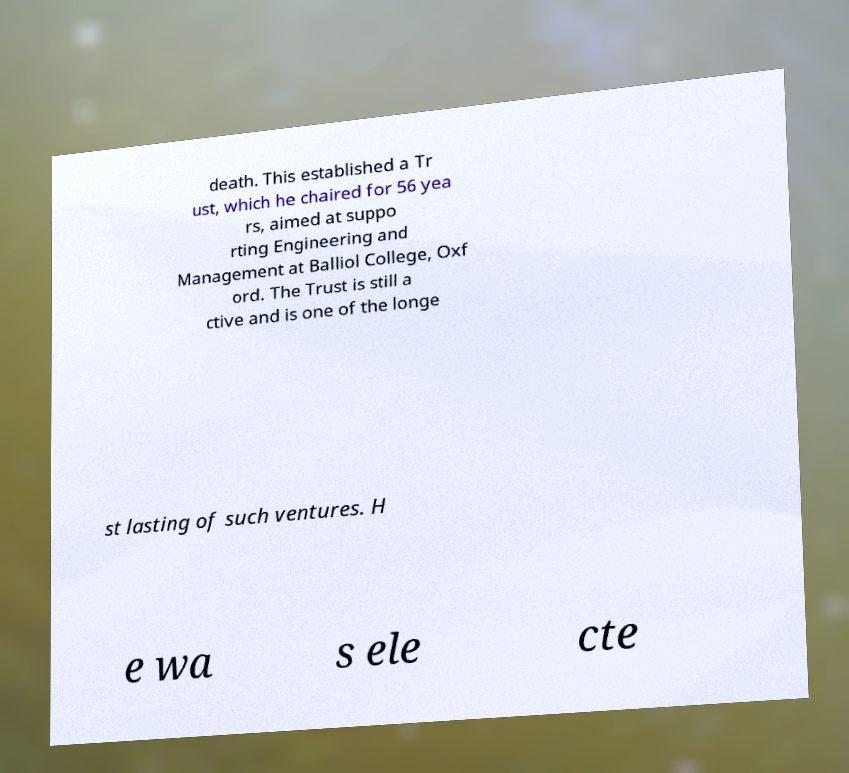Please read and relay the text visible in this image. What does it say? death. This established a Tr ust, which he chaired for 56 yea rs, aimed at suppo rting Engineering and Management at Balliol College, Oxf ord. The Trust is still a ctive and is one of the longe st lasting of such ventures. H e wa s ele cte 